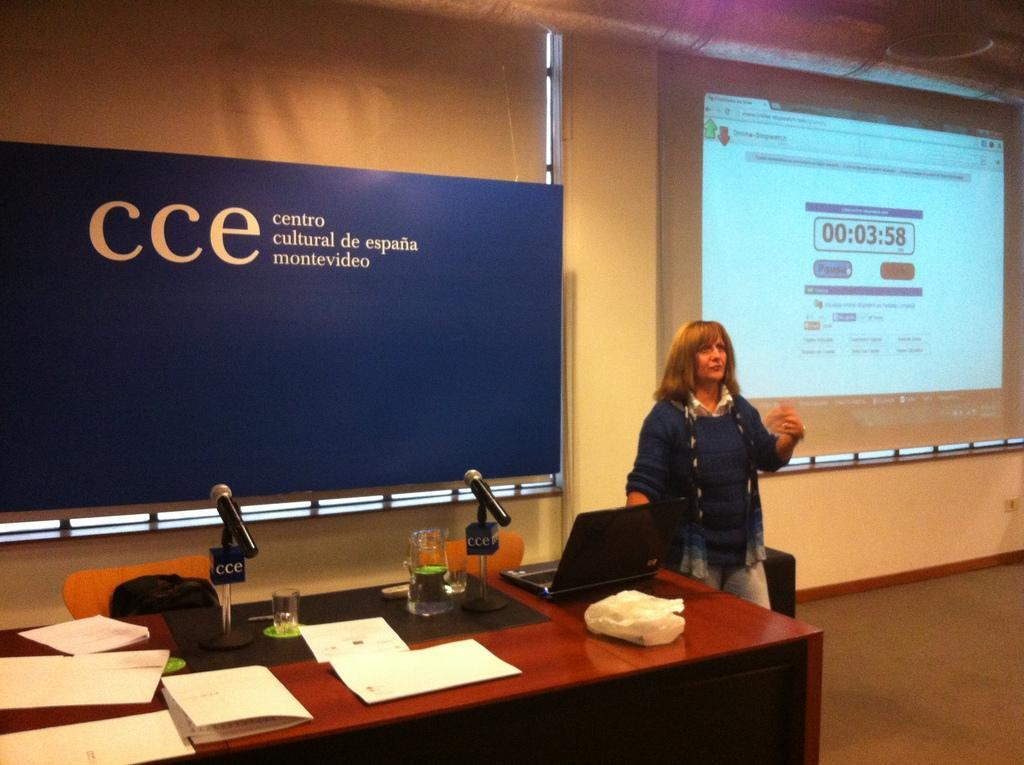Please provide a concise description of this image. Here we can see a woman standing on the floor. This is table. On the table there are glasses, jar, and papers. These are the mikes. On the background there is a wall. This is screen and there is a banner. And these are the chairs. 